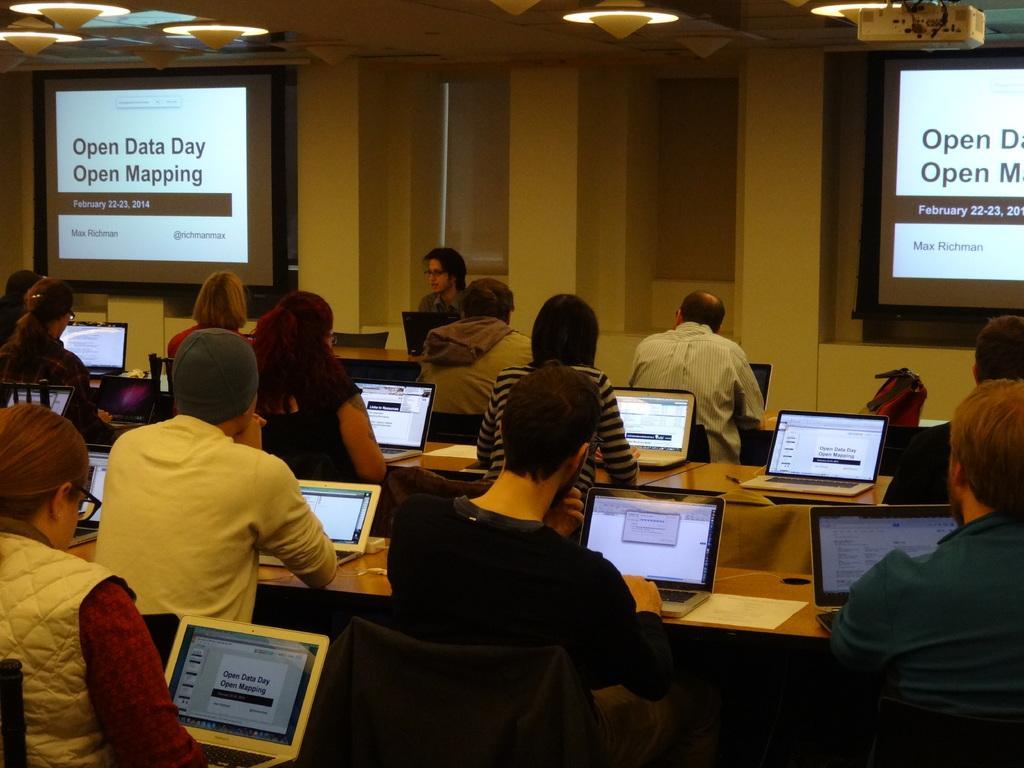Could you give a brief overview of what you see in this image? This is an inside view. Here I can see many people are sitting on the chairs facing towards the back side. In front of these people there are tables on which laptops and papers are placed. Everyone is looking into the laptops. In the background there is a person and windows to the wall. On the right and left side of the image there are two screens on which I can see the text. At the top of the image there are few lights. 